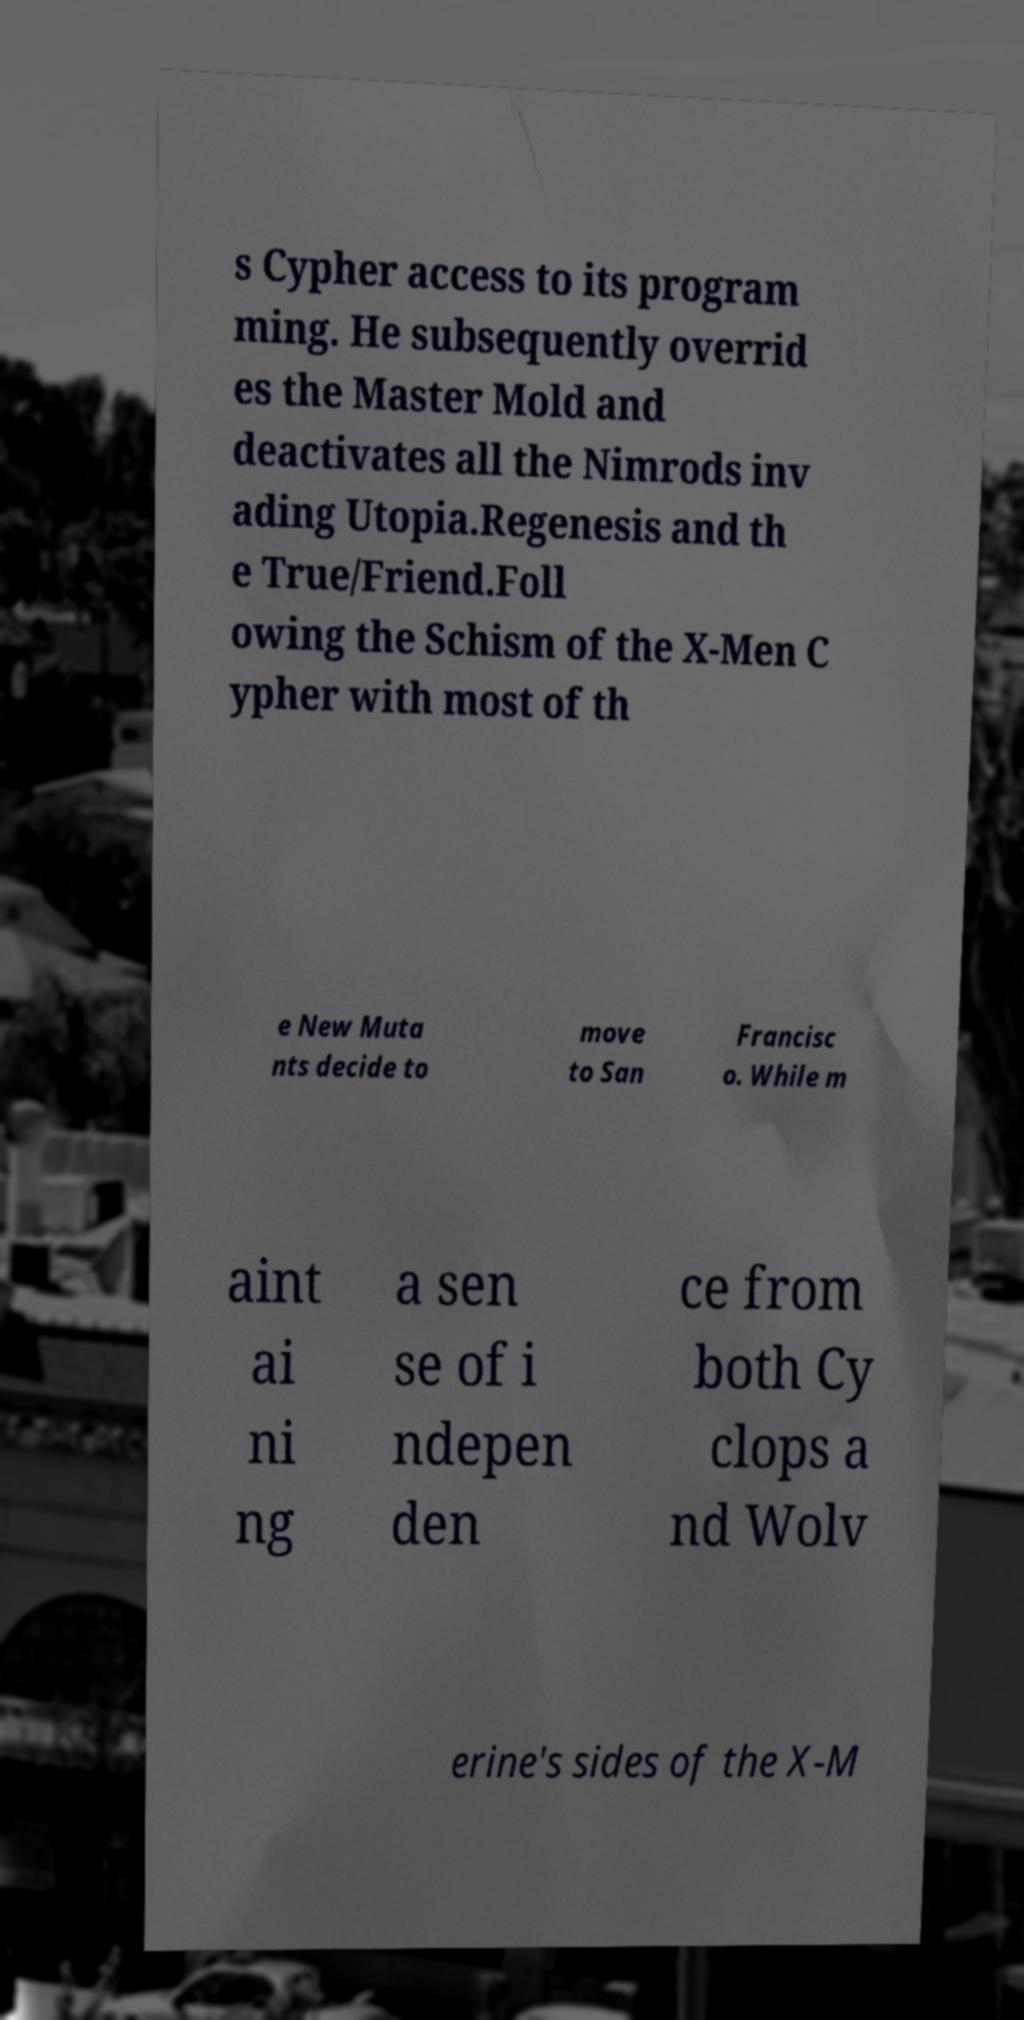Could you extract and type out the text from this image? s Cypher access to its program ming. He subsequently overrid es the Master Mold and deactivates all the Nimrods inv ading Utopia.Regenesis and th e True/Friend.Foll owing the Schism of the X-Men C ypher with most of th e New Muta nts decide to move to San Francisc o. While m aint ai ni ng a sen se of i ndepen den ce from both Cy clops a nd Wolv erine's sides of the X-M 